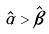Convert formula to latex. <formula><loc_0><loc_0><loc_500><loc_500>\hat { \alpha } > \hat { \beta }</formula> 